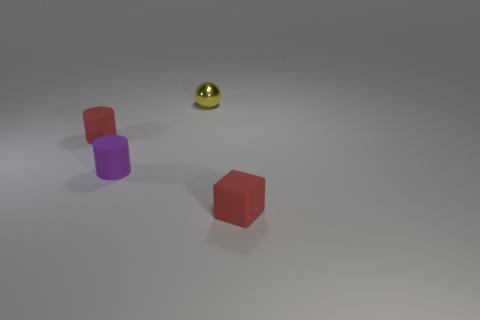Do the tiny object that is behind the tiny red cylinder and the rubber cylinder in front of the red rubber cylinder have the same color? no 